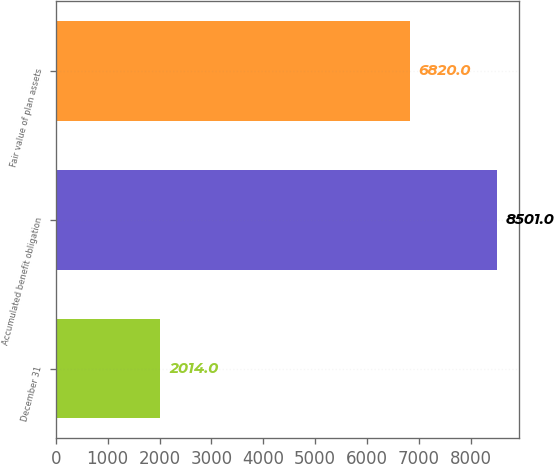Convert chart to OTSL. <chart><loc_0><loc_0><loc_500><loc_500><bar_chart><fcel>December 31<fcel>Accumulated benefit obligation<fcel>Fair value of plan assets<nl><fcel>2014<fcel>8501<fcel>6820<nl></chart> 